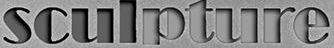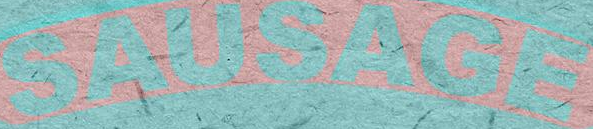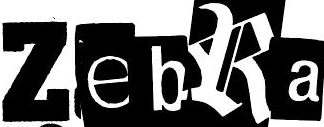Read the text content from these images in order, separated by a semicolon. sculpture; SAUSAGE; ZebRa 